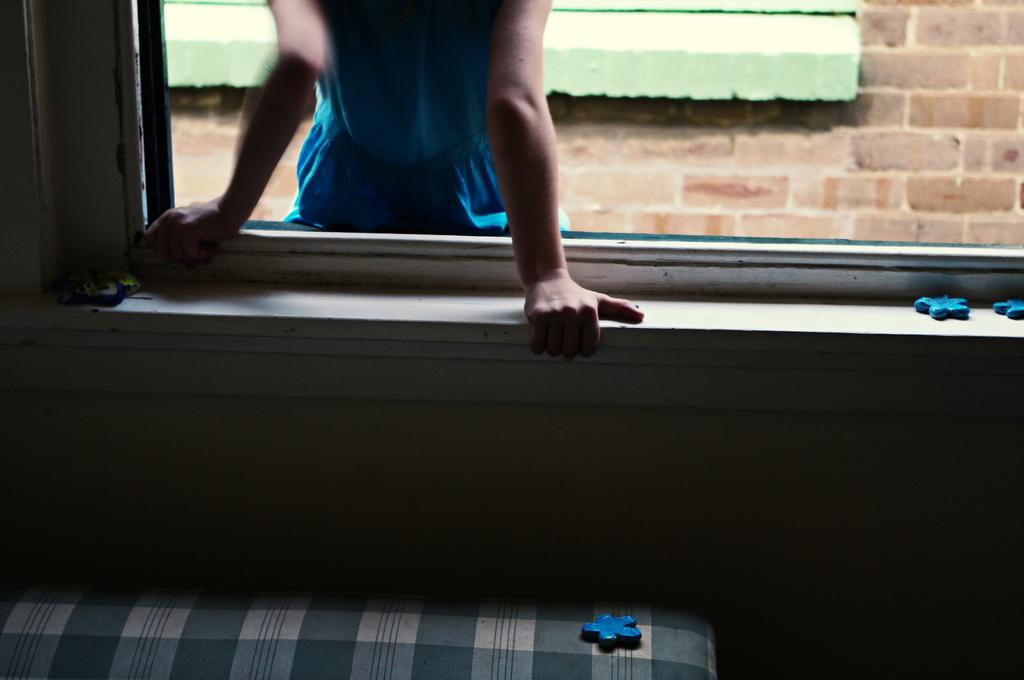What is located at the bottom of the image? There is a bed at the bottom of the image. What can be seen in the center of the image? There is a window in the center of the image. Who is present in the image? There is a girl standing in the image. What is the background of the image made up of? There is a wall in the image. What type of locket is the girl holding in the image? There is no locket present in the image; the girl is not holding any object. What kind of doll is sitting on the bed in the image? There is no doll present in the image; the bed is empty. 